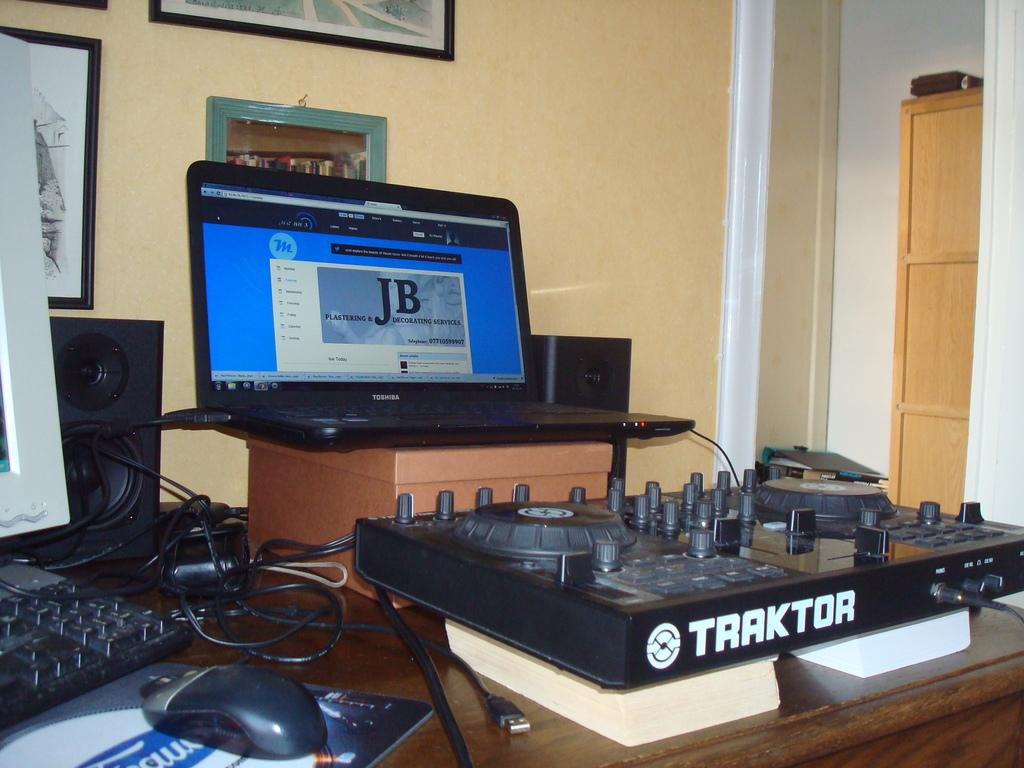<image>
Relay a brief, clear account of the picture shown. A black piece of equipment by Traktor. sits on a table. 